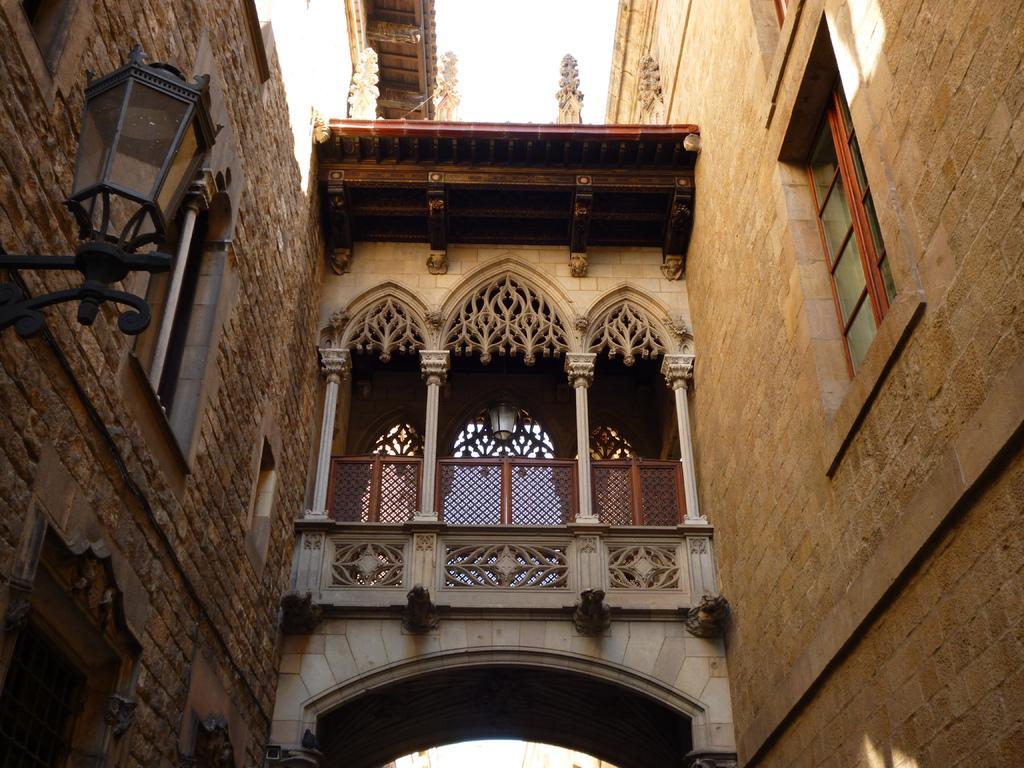Describe this image in one or two sentences. At the left corner of the image there is a wall with lamp and window. At the right corner of the image there is a wall with windows. In the middle of the image there is a building with arch, fencing and pillars. 